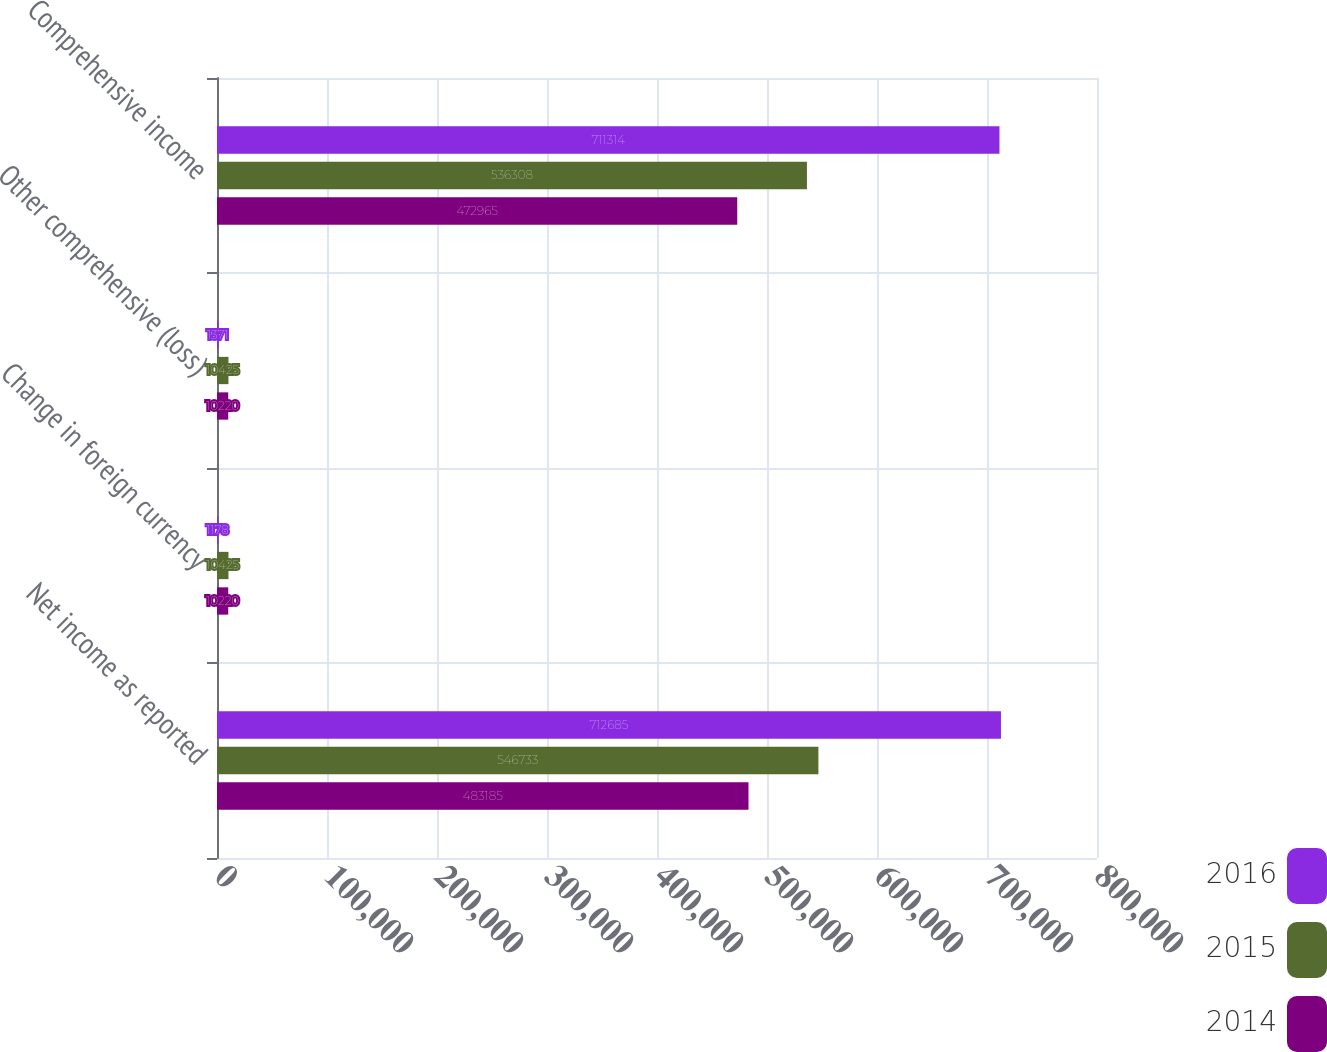Convert chart. <chart><loc_0><loc_0><loc_500><loc_500><stacked_bar_chart><ecel><fcel>Net income as reported<fcel>Change in foreign currency<fcel>Other comprehensive (loss)<fcel>Comprehensive income<nl><fcel>2016<fcel>712685<fcel>1178<fcel>1371<fcel>711314<nl><fcel>2015<fcel>546733<fcel>10425<fcel>10425<fcel>536308<nl><fcel>2014<fcel>483185<fcel>10220<fcel>10220<fcel>472965<nl></chart> 